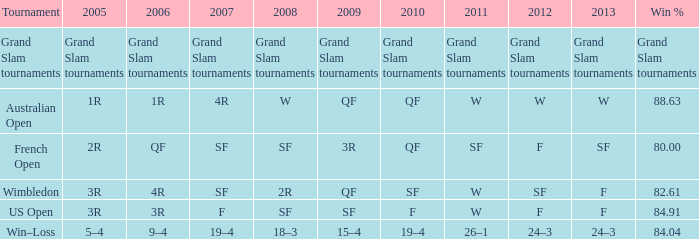What in 2007 has a 2008 of sf, and a 2010 of f? F. 